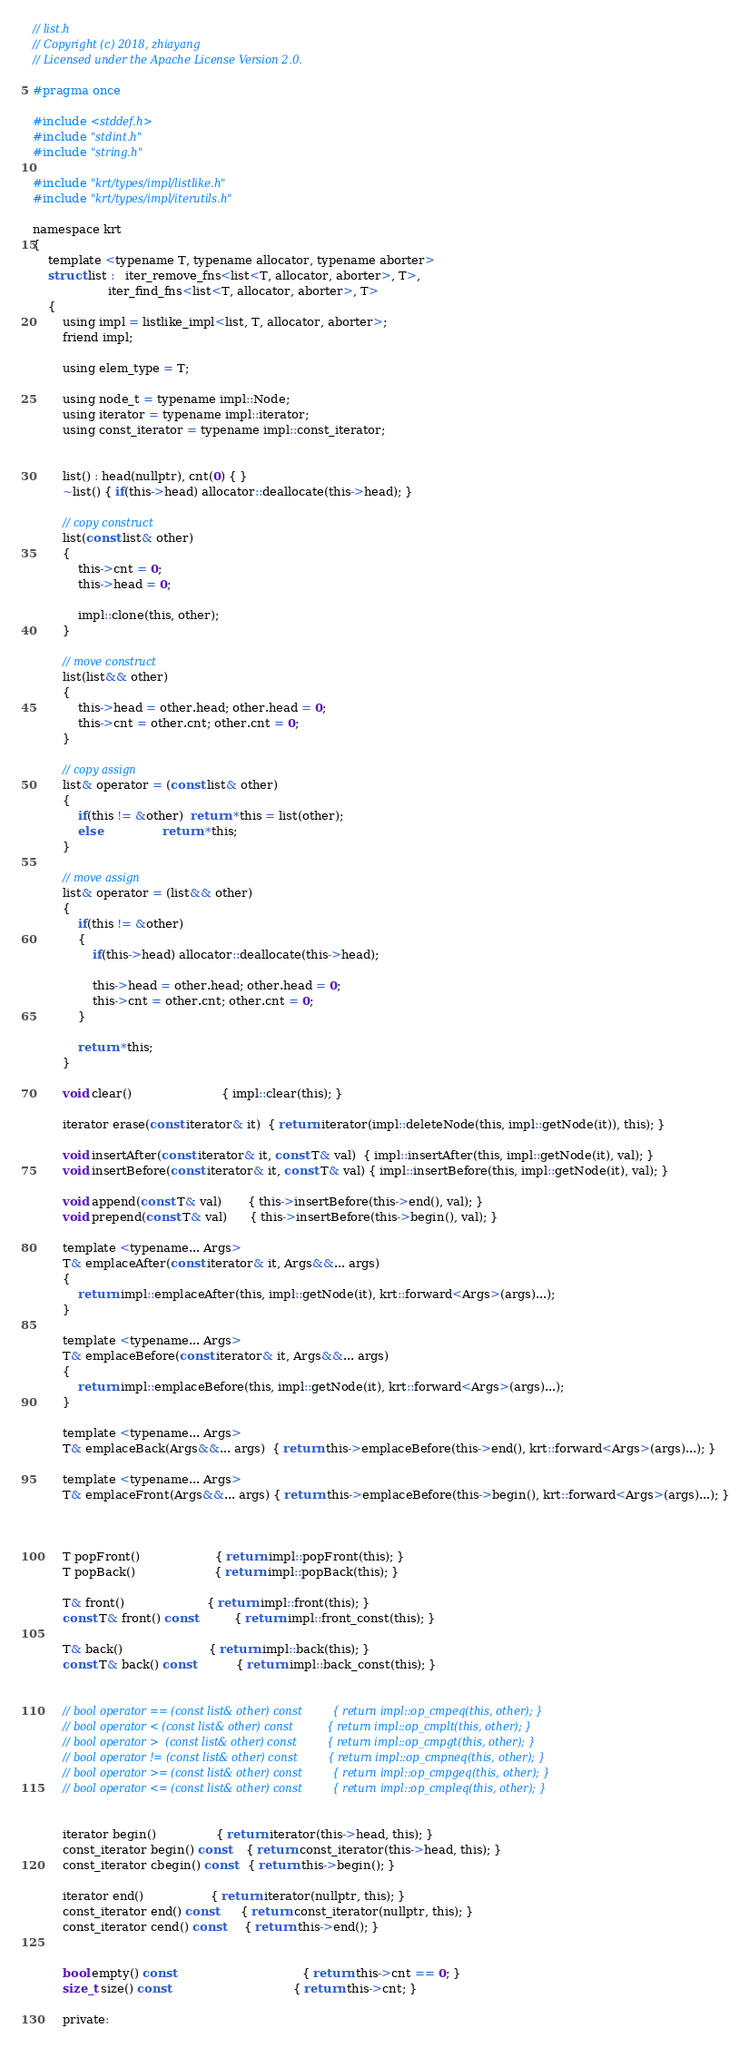<code> <loc_0><loc_0><loc_500><loc_500><_C_>// list.h
// Copyright (c) 2018, zhiayang
// Licensed under the Apache License Version 2.0.

#pragma once

#include <stddef.h>
#include "stdint.h"
#include "string.h"

#include "krt/types/impl/listlike.h"
#include "krt/types/impl/iterutils.h"

namespace krt
{
	template <typename T, typename allocator, typename aborter>
	struct list :   iter_remove_fns<list<T, allocator, aborter>, T>,
					iter_find_fns<list<T, allocator, aborter>, T>
	{
		using impl = listlike_impl<list, T, allocator, aborter>;
		friend impl;

		using elem_type = T;

		using node_t = typename impl::Node;
		using iterator = typename impl::iterator;
		using const_iterator = typename impl::const_iterator;


		list() : head(nullptr), cnt(0) { }
		~list() { if(this->head) allocator::deallocate(this->head); }

		// copy construct
		list(const list& other)
		{
			this->cnt = 0;
			this->head = 0;

			impl::clone(this, other);
		}

		// move construct
		list(list&& other)
		{
			this->head = other.head; other.head = 0;
			this->cnt = other.cnt; other.cnt = 0;
		}

		// copy assign
		list& operator = (const list& other)
		{
			if(this != &other)  return *this = list(other);
			else                return *this;
		}

		// move assign
		list& operator = (list&& other)
		{
			if(this != &other)
			{
				if(this->head) allocator::deallocate(this->head);

				this->head = other.head; other.head = 0;
				this->cnt = other.cnt; other.cnt = 0;
			}

			return *this;
		}

		void clear()                        { impl::clear(this); }

		iterator erase(const iterator& it)  { return iterator(impl::deleteNode(this, impl::getNode(it)), this); }

		void insertAfter(const iterator& it, const T& val)  { impl::insertAfter(this, impl::getNode(it), val); }
		void insertBefore(const iterator& it, const T& val) { impl::insertBefore(this, impl::getNode(it), val); }

		void append(const T& val)       { this->insertBefore(this->end(), val); }
		void prepend(const T& val)      { this->insertBefore(this->begin(), val); }

		template <typename... Args>
		T& emplaceAfter(const iterator& it, Args&&... args)
		{
			return impl::emplaceAfter(this, impl::getNode(it), krt::forward<Args>(args)...);
		}

		template <typename... Args>
		T& emplaceBefore(const iterator& it, Args&&... args)
		{
			return impl::emplaceBefore(this, impl::getNode(it), krt::forward<Args>(args)...);
		}

		template <typename... Args>
		T& emplaceBack(Args&&... args)  { return this->emplaceBefore(this->end(), krt::forward<Args>(args)...); }

		template <typename... Args>
		T& emplaceFront(Args&&... args) { return this->emplaceBefore(this->begin(), krt::forward<Args>(args)...); }



		T popFront()                    { return impl::popFront(this); }
		T popBack()                     { return impl::popBack(this); }

		T& front()                      { return impl::front(this); }
		const T& front() const          { return impl::front_const(this); }

		T& back()                       { return impl::back(this); }
		const T& back() const           { return impl::back_const(this); }


		// bool operator == (const list& other) const         { return impl::op_cmpeq(this, other); }
		// bool operator < (const list& other) const          { return impl::op_cmplt(this, other); }
		// bool operator >  (const list& other) const         { return impl::op_cmpgt(this, other); }
		// bool operator != (const list& other) const         { return impl::op_cmpneq(this, other); }
		// bool operator >= (const list& other) const         { return impl::op_cmpgeq(this, other); }
		// bool operator <= (const list& other) const         { return impl::op_cmpleq(this, other); }


		iterator begin()                { return iterator(this->head, this); }
		const_iterator begin() const    { return const_iterator(this->head, this); }
		const_iterator cbegin() const   { return this->begin(); }

		iterator end()                  { return iterator(nullptr, this); }
		const_iterator end() const      { return const_iterator(nullptr, this); }
		const_iterator cend() const     { return this->end(); }


		bool empty() const                                  { return this->cnt == 0; }
		size_t size() const                                 { return this->cnt; }

		private:</code> 